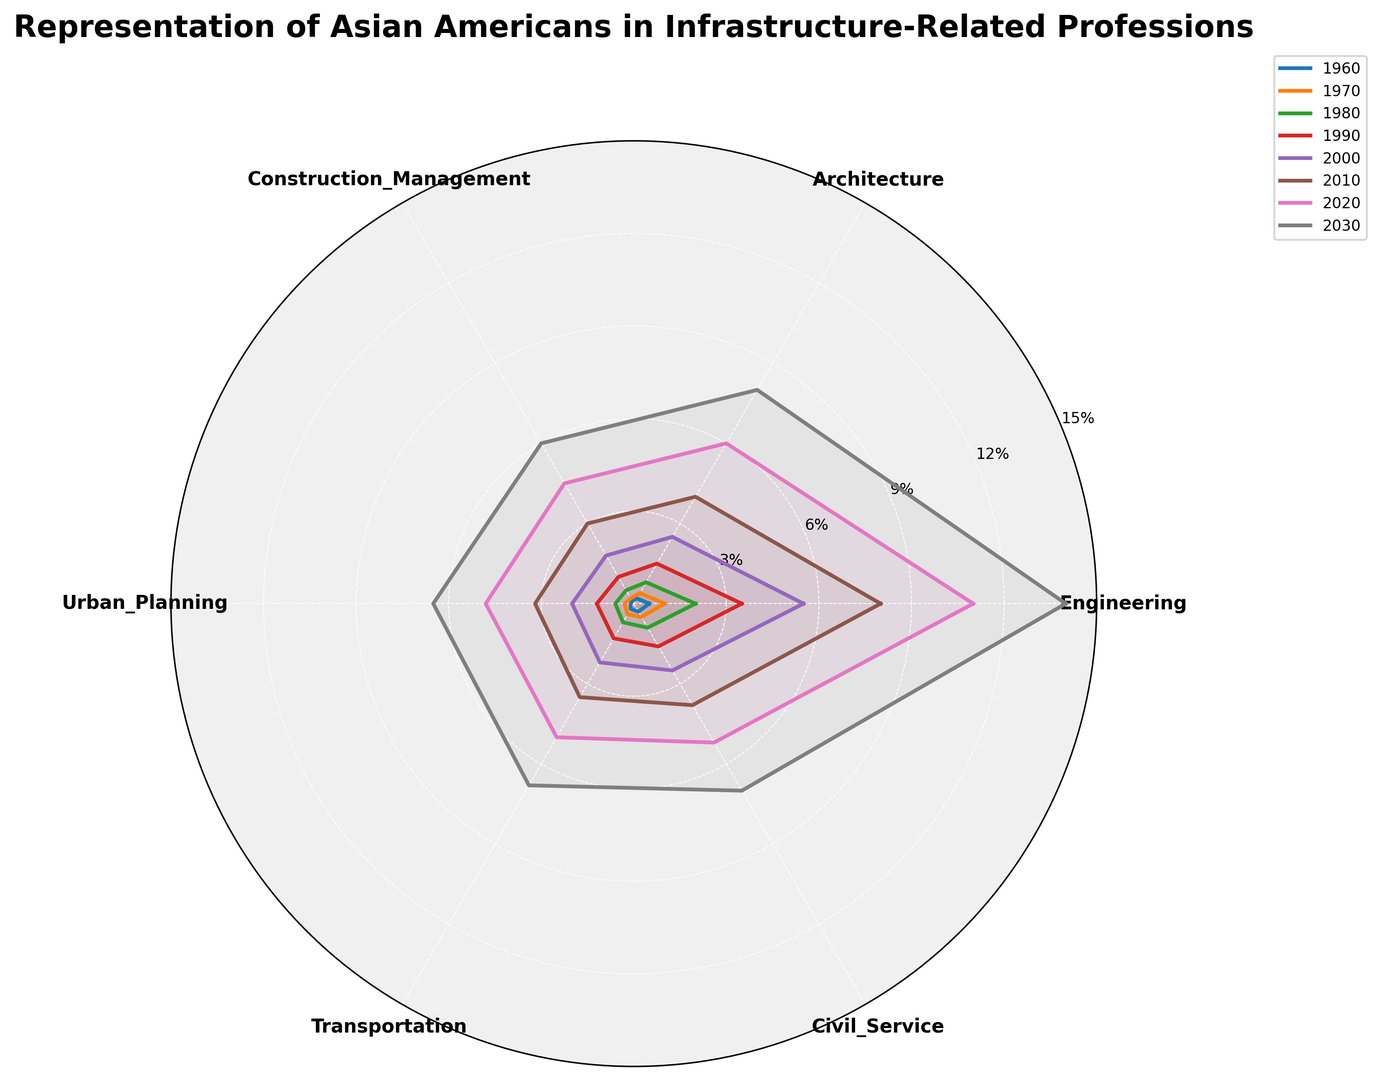Which year had the highest representation in Urban Planning? By checking the lengths of the lines corresponding to Urban Planning for each year, the longest one appears to be for the year 2030.
Answer: 2030 How did the representation in Engineering change between 1960 and 2020? The representation in Engineering in 1960 was 0.5%, and in 2020, it was 11%. Subtracting these values, the change is 11% - 0.5% = 10.5%.
Answer: Increased by 10.5% Which profession had the most even distribution across the years? By visually comparing the sizes of the represented areas for each profession across the years, Transportation and Urban Planning appear to be more evenly distributed than others.
Answer: Transportation and Urban Planning In which profession did Asian Americans see the greatest growth from 1970 to 2010? By examining the increment in each category from 1970 to 2010: Engineering (8% - 1% = 7%), Architecture (4% - 0.4% = 3.6%), Construction Management (3% - 0.2% = 2.8%), Urban Planning (3.2% - 0.3% = 2.9%), Transportation (3.5% - 0.4% = 3.1%), Civil Service (3.8% - 0.5% = 3.3%). Engineering has the highest growth.
Answer: Engineering Compare the representation in Civil Service between 1980 and 2000. The representation in Civil Service in 1980 was 0.9% and in 2000 it was 2.5%. Therefore, between 1980 and 2000, the representation increased by 2.5% - 0.9% = 1.6%.
Answer: Increase by 1.6% Which profession had the smallest growth between 1990 and 2030? By calculating the growth for each profession: 
Engineering (14% - 3.5% = 10.5%), Architecture (8% - 1.5% = 6.5%), Construction Management (6% - 1% = 5%), Urban Planning (6.5% - 1.2% = 5.3%), Transportation (6.8% - 1.3% = 5.5%), Civil Service (7% - 1.6% = 5.4%). Construction Management had the smallest growth.
Answer: Construction Management What's the average representation in Architecture over the years 1960, 1990, 2000, and 2010? Summing up the values for Architecture in the respective years: 0.2% + 1.5% + 2.5% + 4% = 8.2%. The average would be 8.2% / 4 = 2.05%.
Answer: 2.05% Is there any year where the representation in Civil Service surpassed that in Engineering? By visually inspecting the lines for each year, there is no year where the Civil Service representation is higher than Engineering.
Answer: No Did the representation in Transportation grow faster or slower than in Architecture between 1980 and 2020? Growth in Transportation (5% - 0.7% = 4.3%) and in Architecture (6% - 0.8% = 5.2%). Therefore, Architecture grew faster than Transportation.
Answer: Slower What's the ratio of representation in Construction Management to Urban Planning for the year 2010? Representation in 2010: Construction Management = 3%, Urban Planning = 3.2%. The ratio is 3% / 3.2% = 0.9375.
Answer: 0.9375 